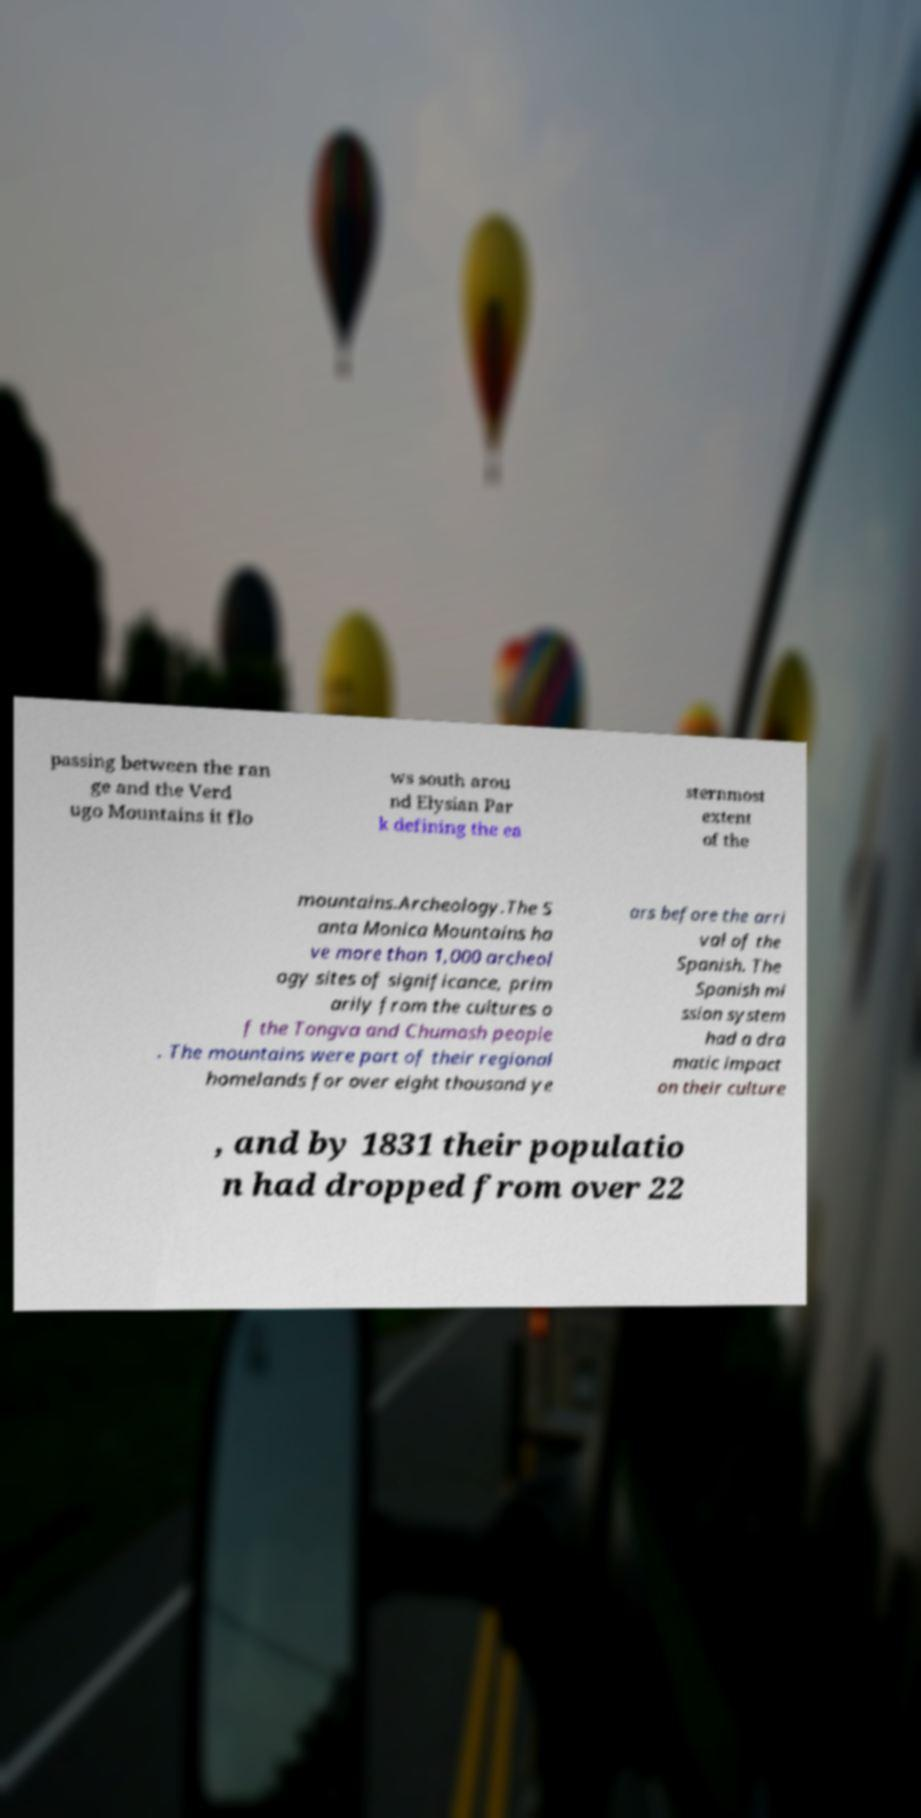Please read and relay the text visible in this image. What does it say? passing between the ran ge and the Verd ugo Mountains it flo ws south arou nd Elysian Par k defining the ea sternmost extent of the mountains.Archeology.The S anta Monica Mountains ha ve more than 1,000 archeol ogy sites of significance, prim arily from the cultures o f the Tongva and Chumash people . The mountains were part of their regional homelands for over eight thousand ye ars before the arri val of the Spanish. The Spanish mi ssion system had a dra matic impact on their culture , and by 1831 their populatio n had dropped from over 22 